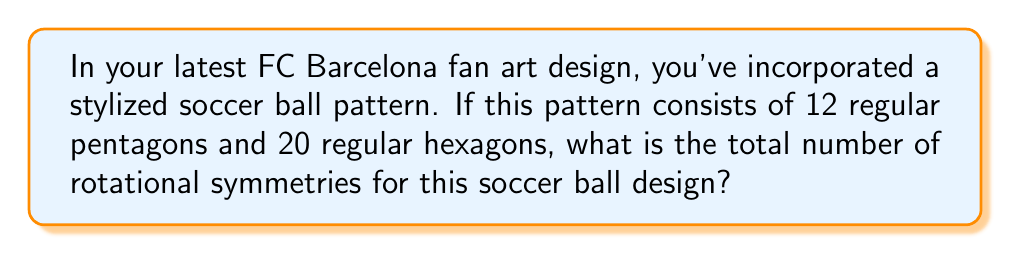Can you solve this math problem? Let's approach this step-by-step:

1) The soccer ball pattern described is known as a truncated icosahedron. It has the same symmetry group as a regular icosahedron.

2) To find the number of rotational symmetries, we need to consider the following:
   a) 5-fold rotational symmetries through the centers of the pentagons
   b) 3-fold rotational symmetries through the centers of the hexagons
   c) 2-fold rotational symmetries through the midpoints of edges

3) Let's count each type:
   a) 5-fold symmetries: There are 12 pentagons, each with 5 rotations: $12 \times (5-1) = 48$
   b) 3-fold symmetries: There are 20 hexagons, each with 3 rotations: $20 \times (3-1) = 40$
   c) 2-fold symmetries: There are 30 edges, each with 1 rotation: $30 \times (2-1) = 30$

4) We also need to include the identity rotation (no rotation at all): 1

5) The total number of rotational symmetries is the sum of all these:

   $$ 48 + 40 + 30 + 1 = 119 $$

6) This result can be verified using the formula for the order of the rotational symmetry group of an icosahedron:

   $$ |I| = 60 $$

   The full symmetry group (including reflections) has twice this order: $2 \times 60 = 120$

   Subtracting the identity element gives us 119 proper rotations.

Thus, your stylized soccer ball design has 119 rotational symmetries.
Answer: 119 